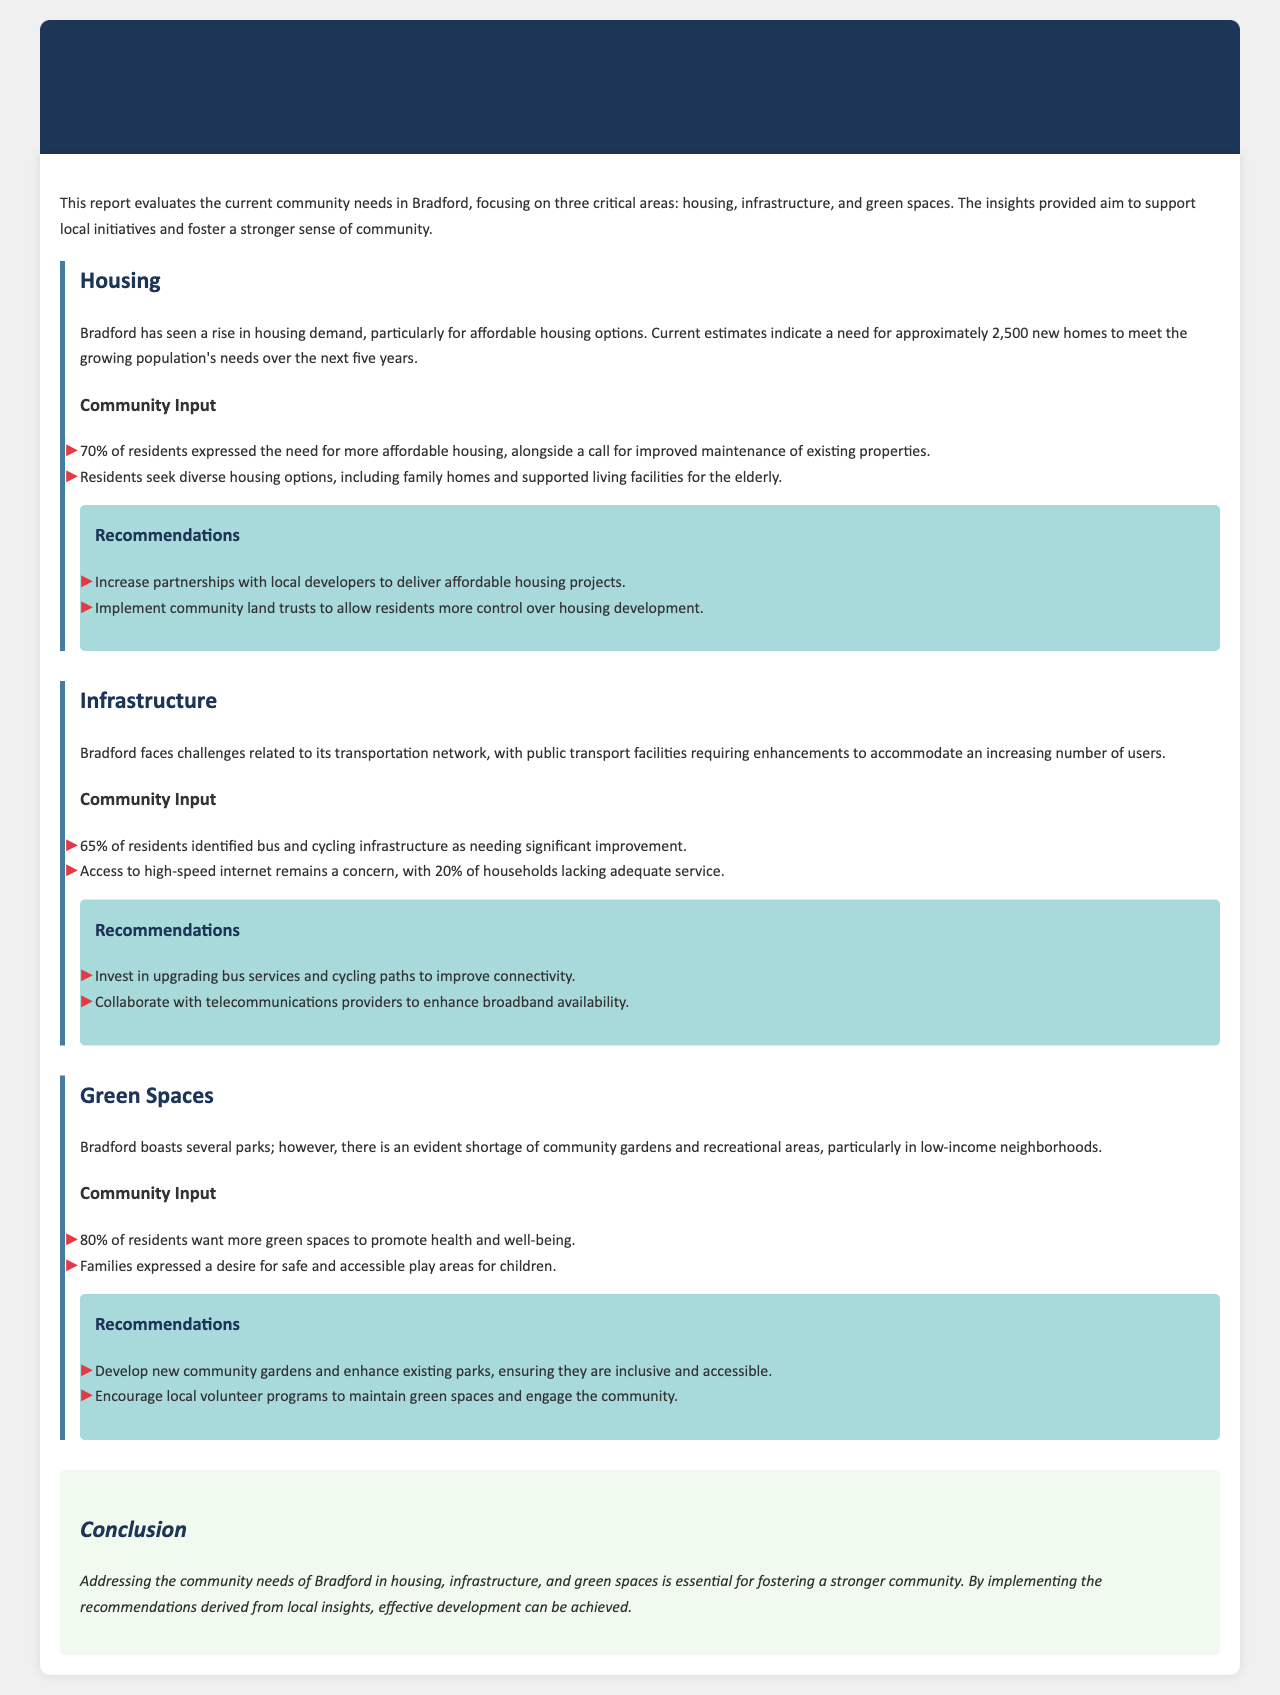what is the estimated need for new homes in Bradford? The document states that there is a need for approximately 2,500 new homes to meet the growing population's needs.
Answer: 2,500 what percentage of residents want more green spaces? The report indicates that 80% of residents expressed the desire for more green spaces.
Answer: 80% what infrastructure improvement did 65% of residents identify? Residents identified that bus and cycling infrastructure needed significant improvement.
Answer: bus and cycling infrastructure what is a recommended action to improve housing in Bradford? The report recommends increasing partnerships with local developers for affordable housing projects.
Answer: Increase partnerships with local developers how many households lack adequate access to high-speed internet? The document notes that 20% of households lack adequate high-speed internet service.
Answer: 20% what type of recreational area is desired by families? Families expressed a desire for safe and accessible play areas for children.
Answer: safe and accessible play areas what is a suggested way to maintain green spaces? The report encourages local volunteer programs to maintain green spaces.
Answer: local volunteer programs what is the primary focus of this Neighborhood Development Report? The report assesses community needs in Bradford focusing on housing, infrastructure, and green spaces.
Answer: housing, infrastructure, and green spaces 